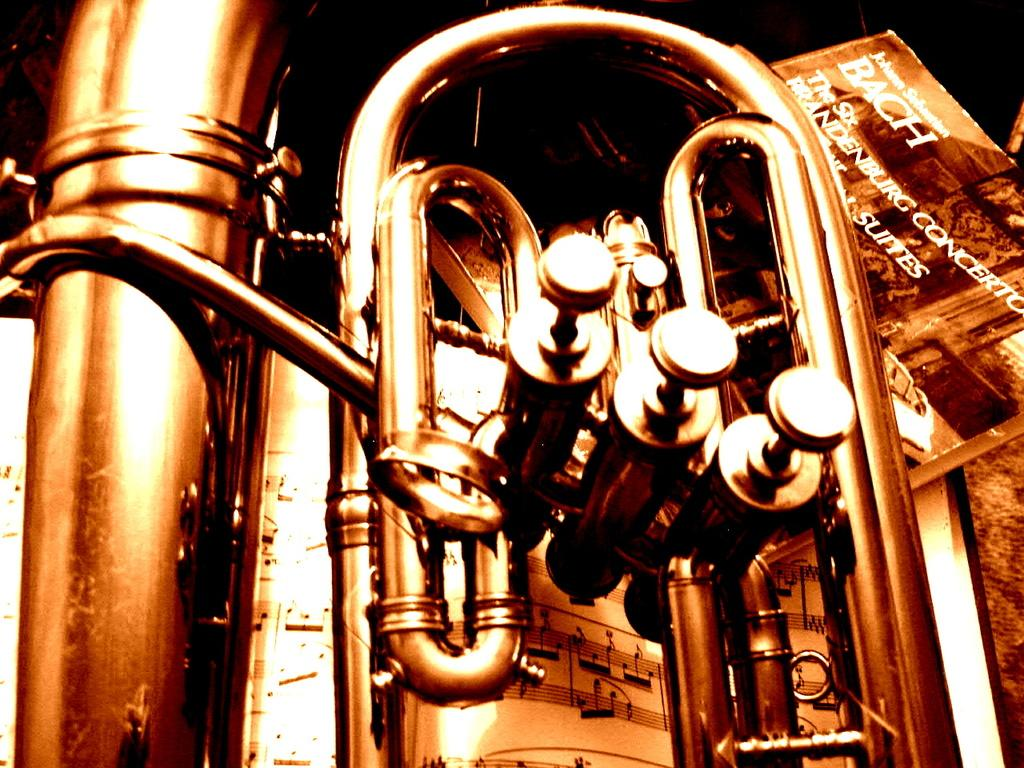What musical instrument is present in the image? There is a trumpet in the image. What is the color of the trumpet? The trumpet is gold in color. What object can be seen on the right side of the image? There is a book on the right side of the image. How would you describe the background of the image? The background of the image is dark. What type of scent can be detected coming from the trumpet in the image? There is no indication of a scent in the image, as it features a gold trumpet and a book on a dark background. 